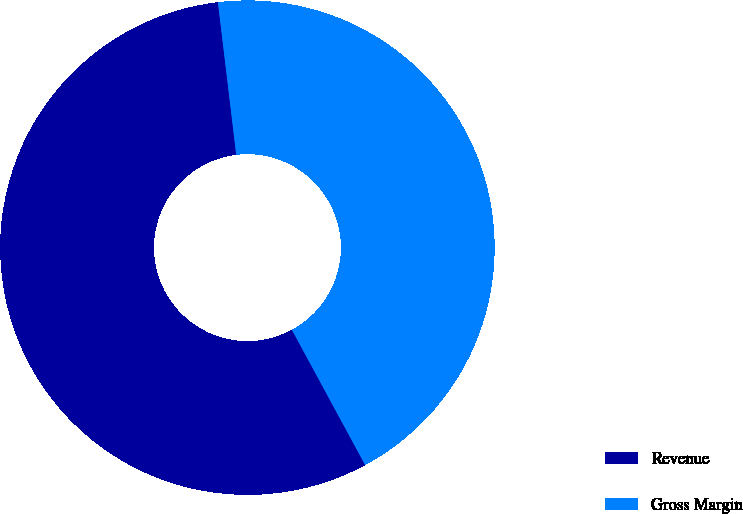Convert chart. <chart><loc_0><loc_0><loc_500><loc_500><pie_chart><fcel>Revenue<fcel>Gross Margin<nl><fcel>56.0%<fcel>44.0%<nl></chart> 